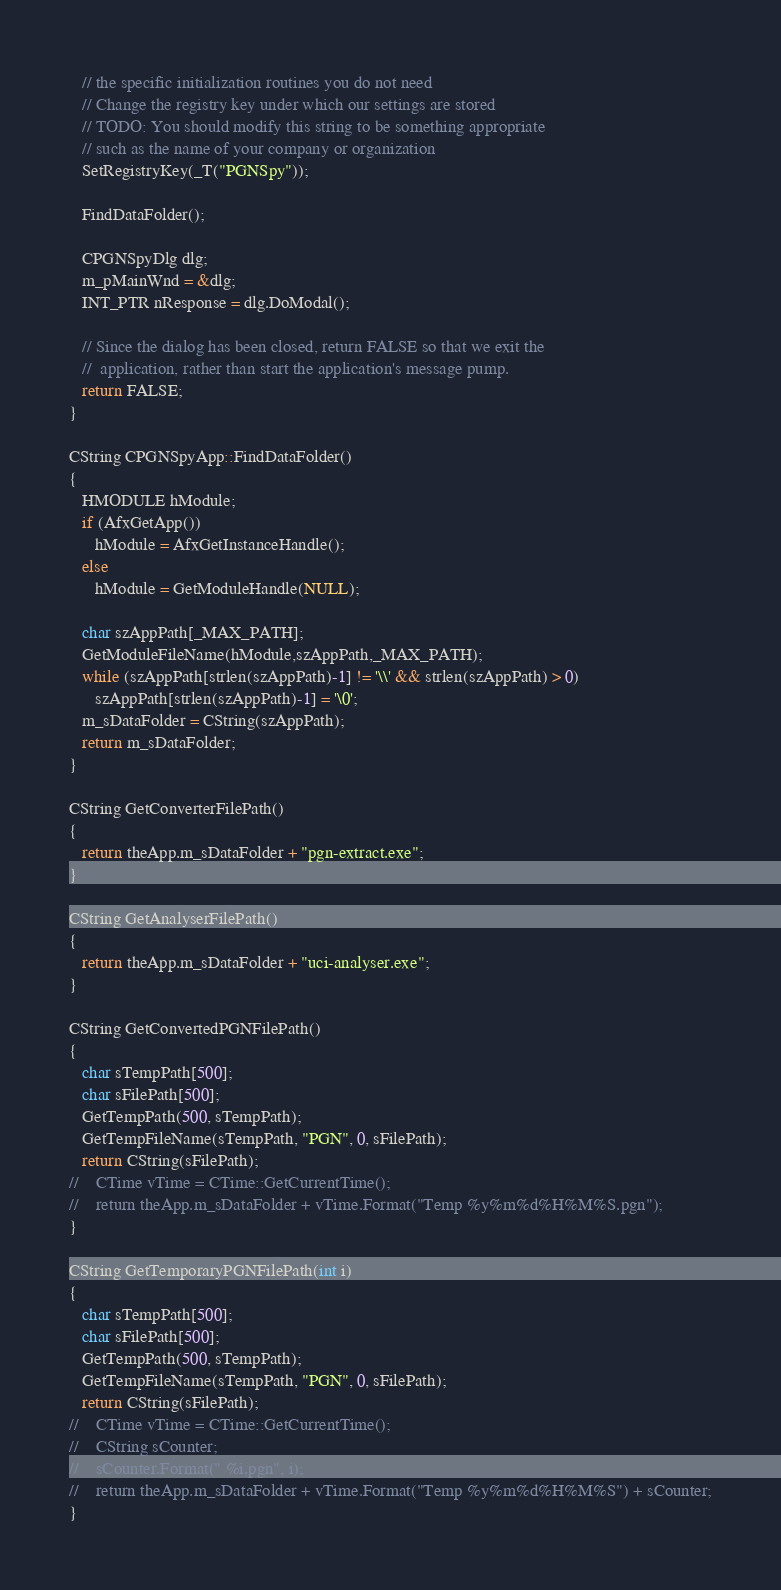<code> <loc_0><loc_0><loc_500><loc_500><_C++_>   // the specific initialization routines you do not need
   // Change the registry key under which our settings are stored
   // TODO: You should modify this string to be something appropriate
   // such as the name of your company or organization
   SetRegistryKey(_T("PGNSpy"));

   FindDataFolder();

   CPGNSpyDlg dlg;
   m_pMainWnd = &dlg;
   INT_PTR nResponse = dlg.DoModal();

   // Since the dialog has been closed, return FALSE so that we exit the
   //  application, rather than start the application's message pump.
   return FALSE;
}

CString CPGNSpyApp::FindDataFolder()
{
   HMODULE hModule;
   if (AfxGetApp())
      hModule = AfxGetInstanceHandle();
   else
      hModule = GetModuleHandle(NULL);

   char szAppPath[_MAX_PATH];
   GetModuleFileName(hModule,szAppPath,_MAX_PATH);
   while (szAppPath[strlen(szAppPath)-1] != '\\' && strlen(szAppPath) > 0)
      szAppPath[strlen(szAppPath)-1] = '\0';
   m_sDataFolder = CString(szAppPath);
   return m_sDataFolder;
}

CString GetConverterFilePath()
{
   return theApp.m_sDataFolder + "pgn-extract.exe";
}

CString GetAnalyserFilePath()
{
   return theApp.m_sDataFolder + "uci-analyser.exe";
}

CString GetConvertedPGNFilePath()
{
   char sTempPath[500];
   char sFilePath[500];
   GetTempPath(500, sTempPath);
   GetTempFileName(sTempPath, "PGN", 0, sFilePath);
   return CString(sFilePath);
//    CTime vTime = CTime::GetCurrentTime();
//    return theApp.m_sDataFolder + vTime.Format("Temp %y%m%d%H%M%S.pgn");
}

CString GetTemporaryPGNFilePath(int i)
{
   char sTempPath[500];
   char sFilePath[500];
   GetTempPath(500, sTempPath);
   GetTempFileName(sTempPath, "PGN", 0, sFilePath);
   return CString(sFilePath);
//    CTime vTime = CTime::GetCurrentTime();
//    CString sCounter;
//    sCounter.Format(" %i.pgn", i);
//    return theApp.m_sDataFolder + vTime.Format("Temp %y%m%d%H%M%S") + sCounter;
}
</code> 